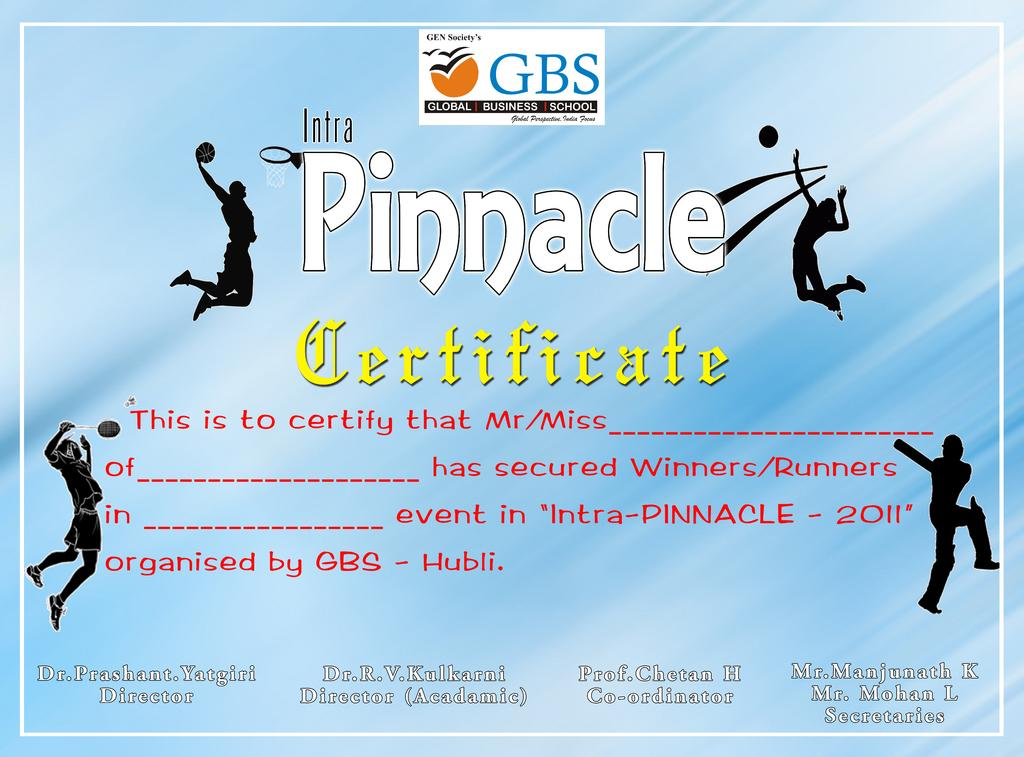<image>
Render a clear and concise summary of the photo. Reward certificate for the Intra Pinnacle 2011 from Global Business School 